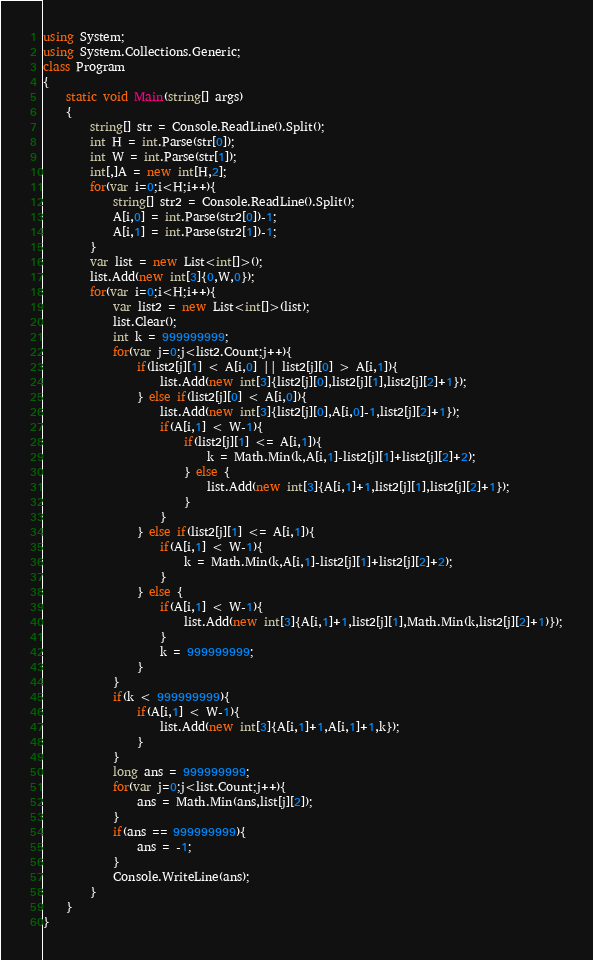Convert code to text. <code><loc_0><loc_0><loc_500><loc_500><_C#_>using System;
using System.Collections.Generic;
class Program
{
	static void Main(string[] args)
	{
		string[] str = Console.ReadLine().Split();
		int H = int.Parse(str[0]);
		int W = int.Parse(str[1]);
		int[,]A = new int[H,2];
		for(var i=0;i<H;i++){
			string[] str2 = Console.ReadLine().Split();
			A[i,0] = int.Parse(str2[0])-1;
			A[i,1] = int.Parse(str2[1])-1;
		}
		var list = new List<int[]>();
		list.Add(new int[3]{0,W,0});
		for(var i=0;i<H;i++){
			var list2 = new List<int[]>(list);
			list.Clear();
			int k = 999999999;
			for(var j=0;j<list2.Count;j++){
				if(list2[j][1] < A[i,0] || list2[j][0] > A[i,1]){
					list.Add(new int[3]{list2[j][0],list2[j][1],list2[j][2]+1});
				} else if(list2[j][0] < A[i,0]){
					list.Add(new int[3]{list2[j][0],A[i,0]-1,list2[j][2]+1});
					if(A[i,1] < W-1){
						if(list2[j][1] <= A[i,1]){
 							k = Math.Min(k,A[i,1]-list2[j][1]+list2[j][2]+2);
						} else {
							list.Add(new int[3]{A[i,1]+1,list2[j][1],list2[j][2]+1});
						}
					}
				} else if(list2[j][1] <= A[i,1]){
					if(A[i,1] < W-1){
						k = Math.Min(k,A[i,1]-list2[j][1]+list2[j][2]+2);
					}
				} else {
					if(A[i,1] < W-1){
						list.Add(new int[3]{A[i,1]+1,list2[j][1],Math.Min(k,list2[j][2]+1)});
					}
					k = 999999999;
				}
			}
			if(k < 999999999){
				if(A[i,1] < W-1){
					list.Add(new int[3]{A[i,1]+1,A[i,1]+1,k});
				}
			}
			long ans = 999999999;
			for(var j=0;j<list.Count;j++){
				ans = Math.Min(ans,list[j][2]);
			}
			if(ans == 999999999){
				ans = -1;
			}
			Console.WriteLine(ans);
		}
	}
}
</code> 